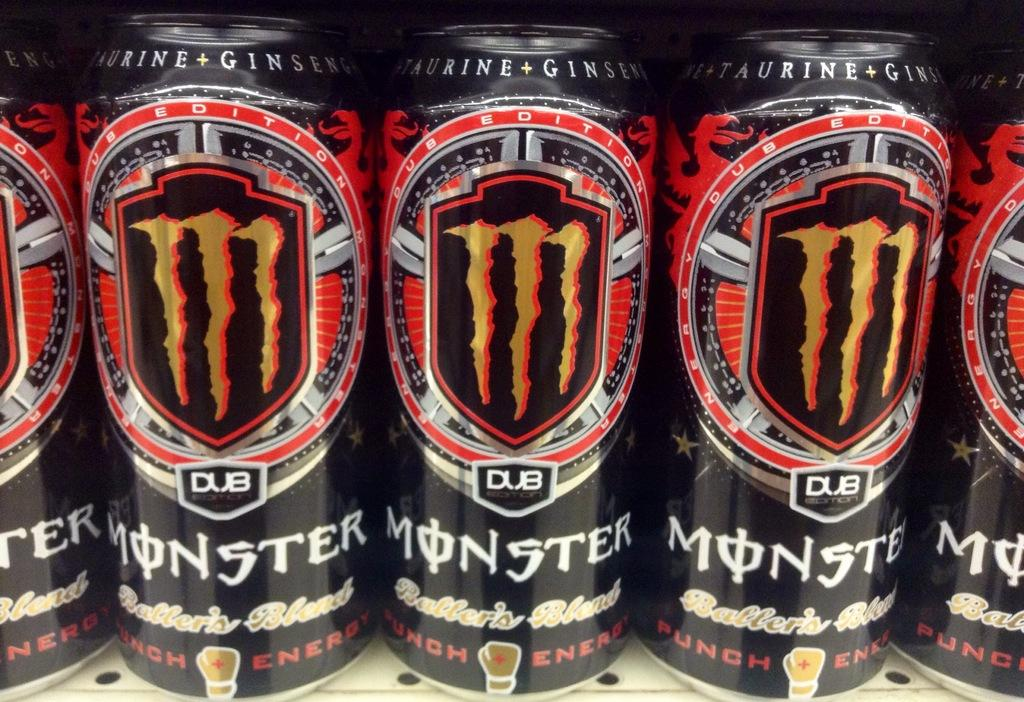<image>
Offer a succinct explanation of the picture presented. a row of canned Monster punch energy drinks 